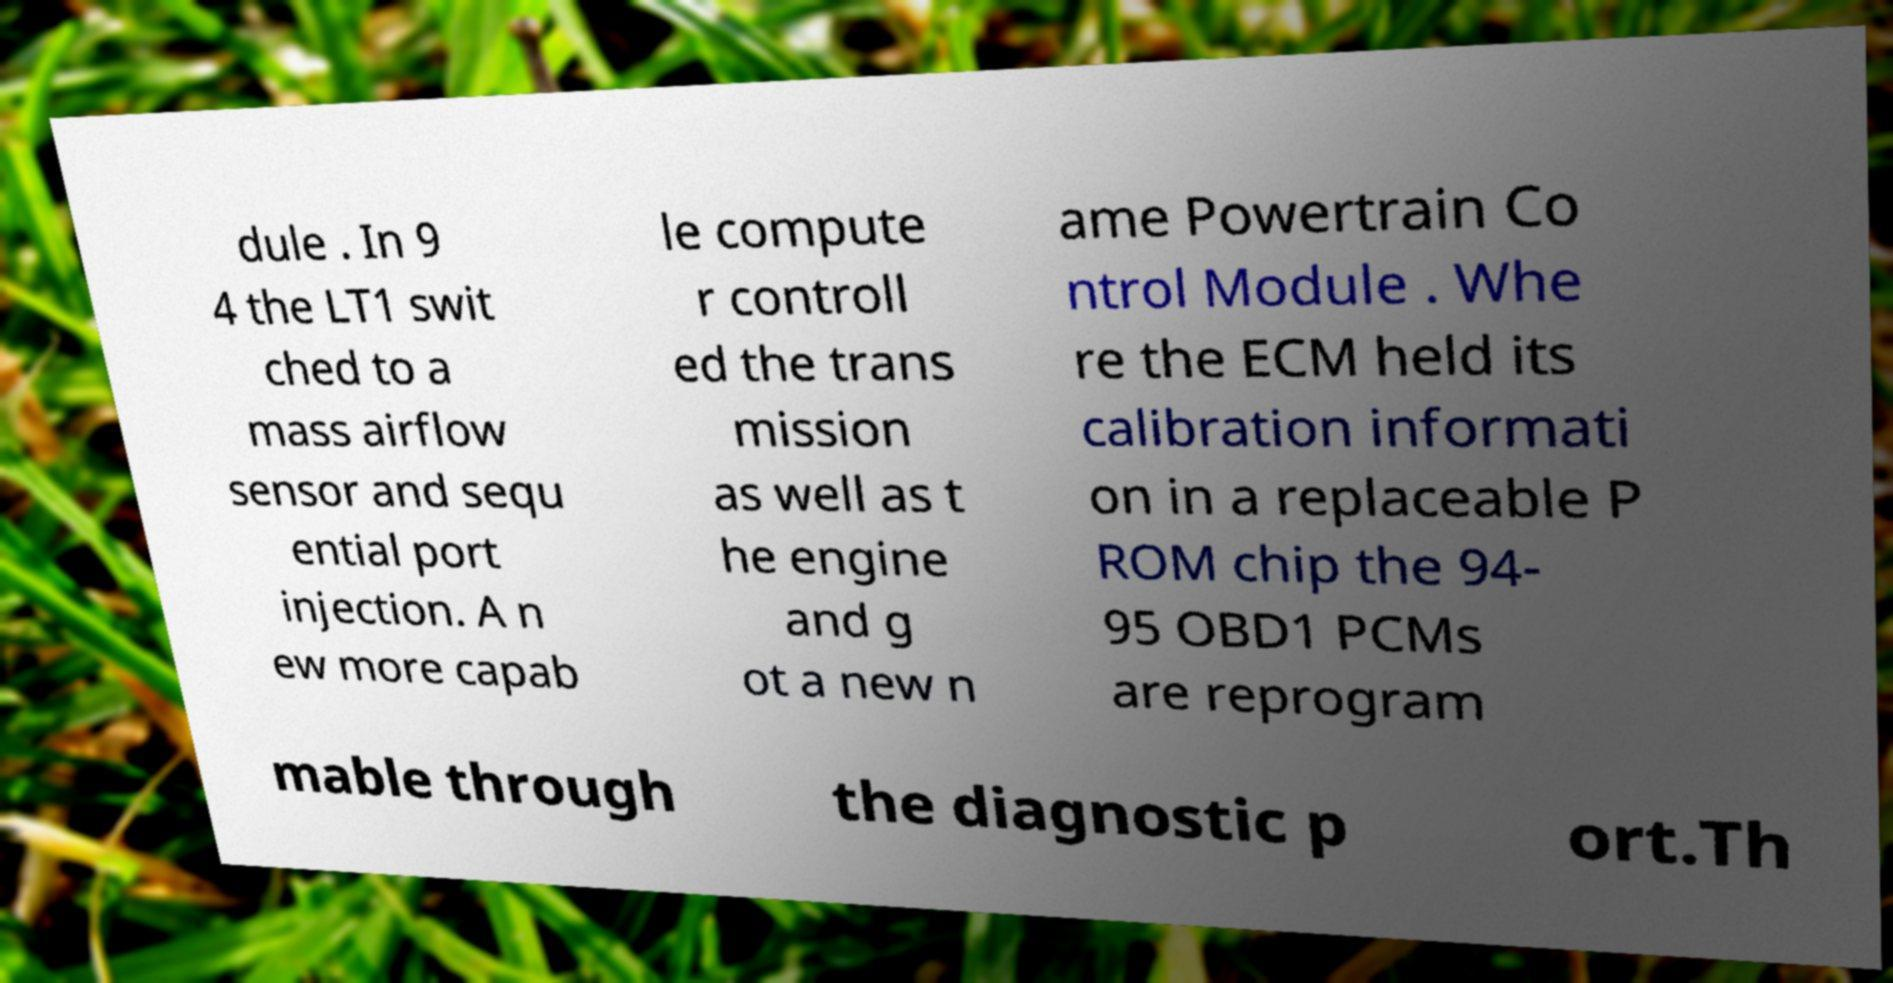What messages or text are displayed in this image? I need them in a readable, typed format. dule . In 9 4 the LT1 swit ched to a mass airflow sensor and sequ ential port injection. A n ew more capab le compute r controll ed the trans mission as well as t he engine and g ot a new n ame Powertrain Co ntrol Module . Whe re the ECM held its calibration informati on in a replaceable P ROM chip the 94- 95 OBD1 PCMs are reprogram mable through the diagnostic p ort.Th 